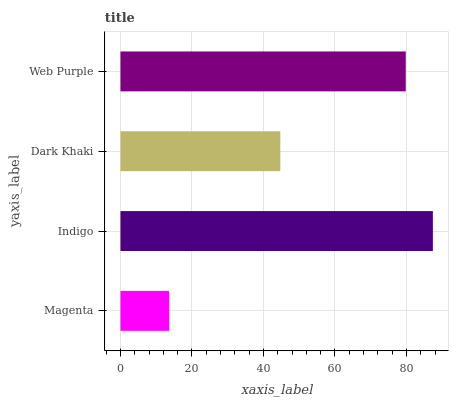Is Magenta the minimum?
Answer yes or no. Yes. Is Indigo the maximum?
Answer yes or no. Yes. Is Dark Khaki the minimum?
Answer yes or no. No. Is Dark Khaki the maximum?
Answer yes or no. No. Is Indigo greater than Dark Khaki?
Answer yes or no. Yes. Is Dark Khaki less than Indigo?
Answer yes or no. Yes. Is Dark Khaki greater than Indigo?
Answer yes or no. No. Is Indigo less than Dark Khaki?
Answer yes or no. No. Is Web Purple the high median?
Answer yes or no. Yes. Is Dark Khaki the low median?
Answer yes or no. Yes. Is Dark Khaki the high median?
Answer yes or no. No. Is Web Purple the low median?
Answer yes or no. No. 